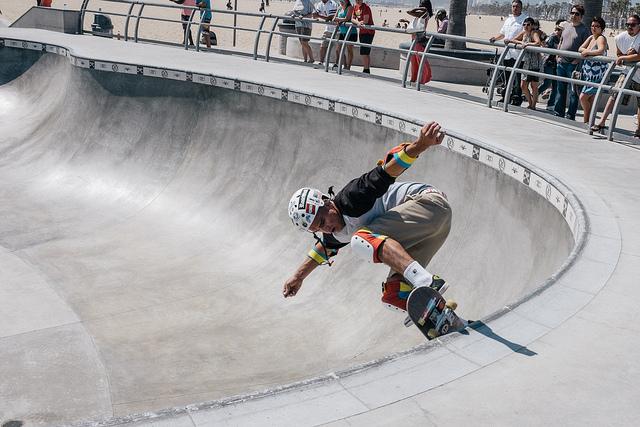Are his knee pads black?
Short answer required. No. Is there a shadow?
Give a very brief answer. Yes. What is the color of his helmet?
Give a very brief answer. White. 